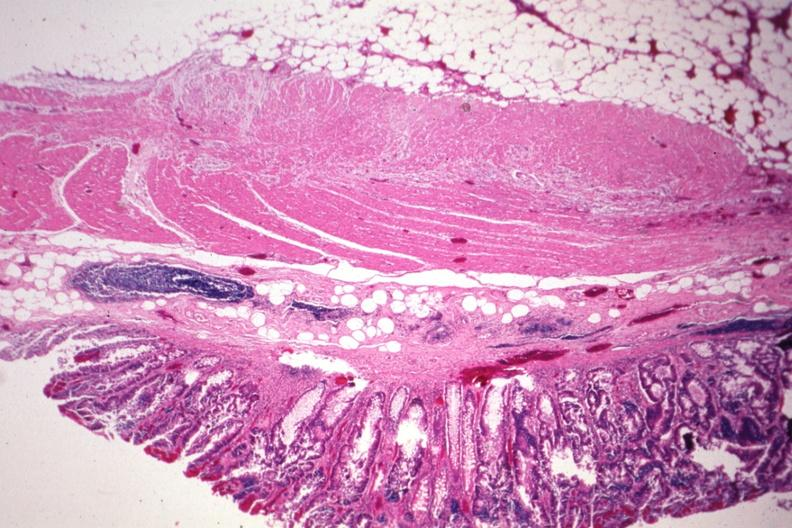where is this from?
Answer the question using a single word or phrase. Gastrointestinal system 